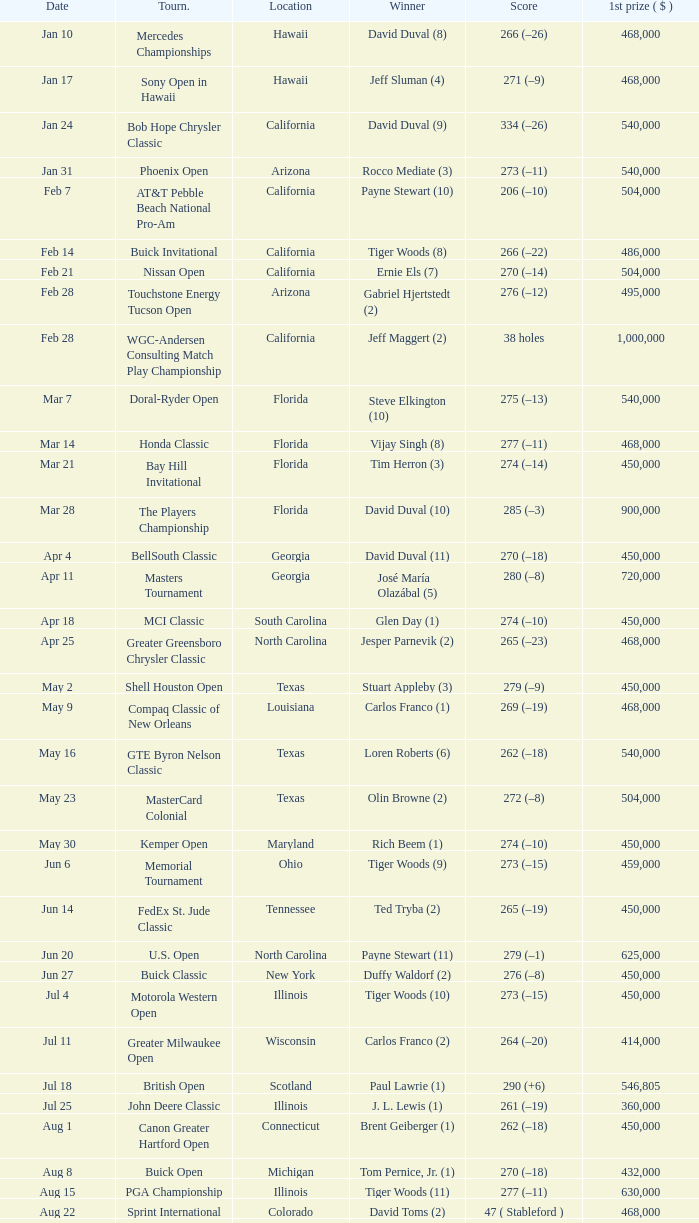What is the score of the B.C. Open in New York? 273 (–15). 